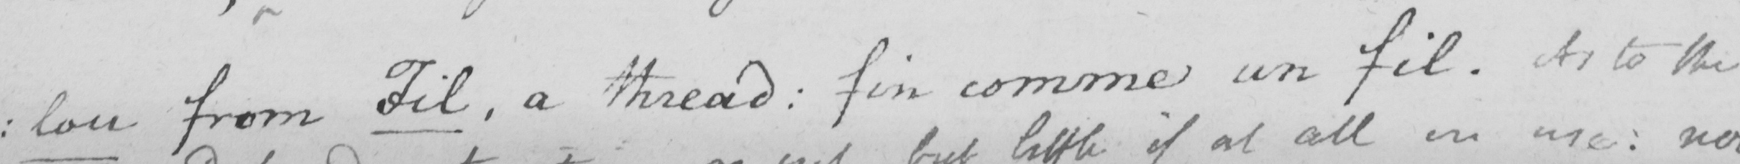Please provide the text content of this handwritten line. lou from Fil , a thread :  fin comme un fil . As to the 